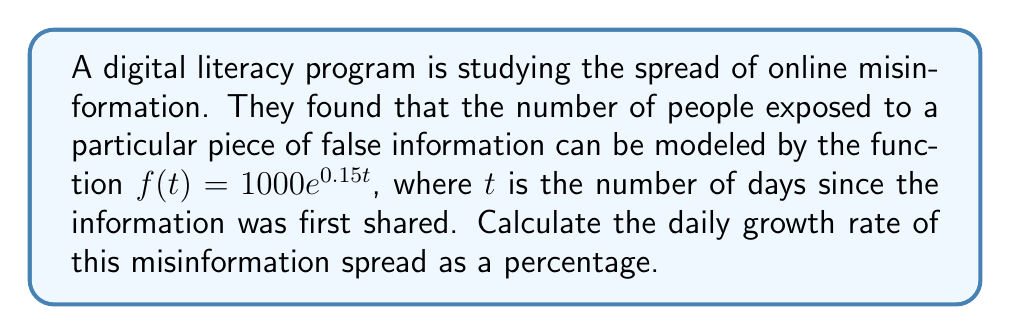Teach me how to tackle this problem. To find the daily growth rate, we need to follow these steps:

1) The general form of an exponential function is:
   $f(t) = a \cdot b^t$

2) In our case, $f(t) = 1000e^{0.15t}$, so $b = e^{0.15}$

3) The daily growth rate is the percentage increase from one day to the next. We can calculate this using:
   $\text{Growth Rate} = (b - 1) \times 100\%$

4) Substituting our value for $b$:
   $\text{Growth Rate} = (e^{0.15} - 1) \times 100\%$

5) Calculate $e^{0.15}$:
   $e^{0.15} \approx 1.1618$

6) Subtract 1 and multiply by 100%:
   $\text{Growth Rate} = (1.1618 - 1) \times 100\% \approx 16.18\%$

Therefore, the daily growth rate of the misinformation spread is approximately 16.18%.
Answer: 16.18% 